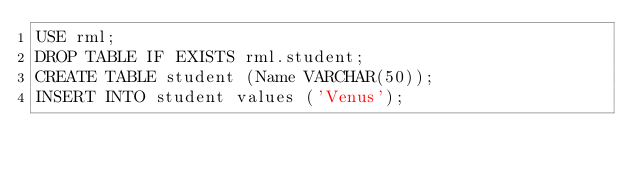<code> <loc_0><loc_0><loc_500><loc_500><_SQL_>USE rml;
DROP TABLE IF EXISTS rml.student;
CREATE TABLE student (Name VARCHAR(50));
INSERT INTO student values ('Venus');</code> 